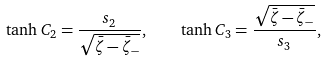Convert formula to latex. <formula><loc_0><loc_0><loc_500><loc_500>\tanh { C _ { 2 } } = \frac { s _ { 2 } } { \sqrt { \bar { \zeta } - \bar { \zeta } _ { - } } } , \quad \tanh { C _ { 3 } } = \frac { \sqrt { \bar { \zeta } - \bar { \zeta } _ { - } } } { s _ { 3 } } ,</formula> 